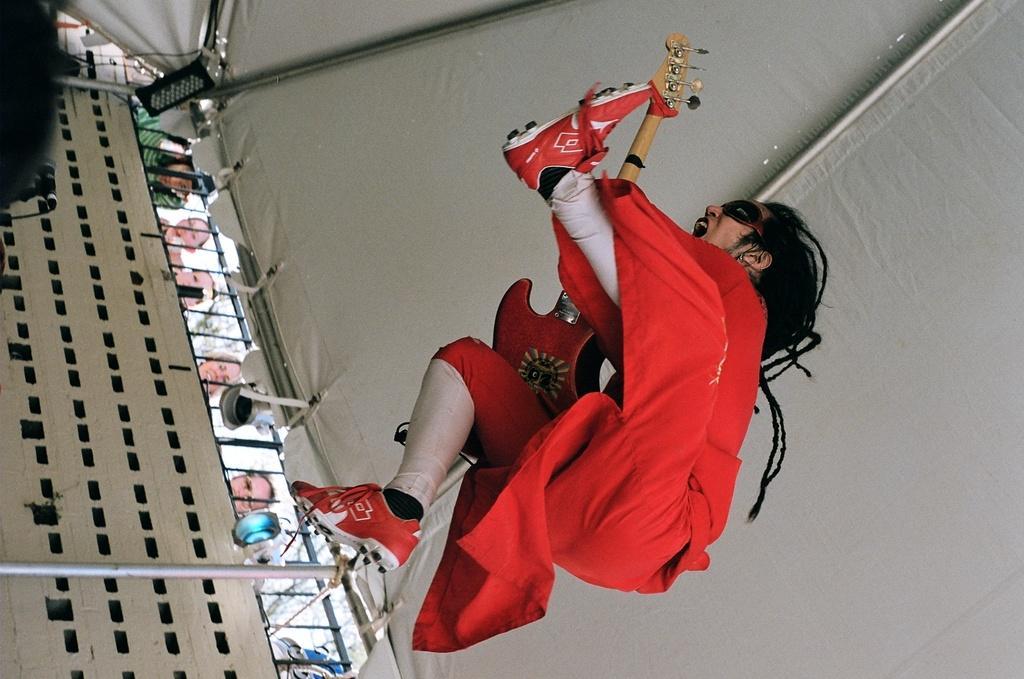Can you describe this image briefly? Here in this picture we can see a person jumping in air and we can see some costume on him and he is holding a guitar in his hand and above him we can see a tent present and we can also see lights present and we can see people trying to see him performing from outside over there and on the left side we can see a microphone also present over there. 